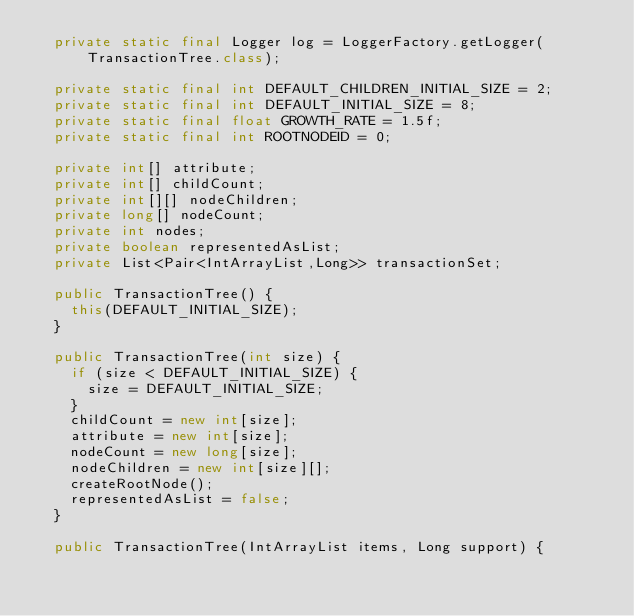Convert code to text. <code><loc_0><loc_0><loc_500><loc_500><_Java_>  private static final Logger log = LoggerFactory.getLogger(TransactionTree.class);

  private static final int DEFAULT_CHILDREN_INITIAL_SIZE = 2;
  private static final int DEFAULT_INITIAL_SIZE = 8;
  private static final float GROWTH_RATE = 1.5f;
  private static final int ROOTNODEID = 0;
  
  private int[] attribute;
  private int[] childCount;
  private int[][] nodeChildren;
  private long[] nodeCount;
  private int nodes;
  private boolean representedAsList;
  private List<Pair<IntArrayList,Long>> transactionSet;
  
  public TransactionTree() {
    this(DEFAULT_INITIAL_SIZE);
  }
  
  public TransactionTree(int size) {
    if (size < DEFAULT_INITIAL_SIZE) {
      size = DEFAULT_INITIAL_SIZE;
    }
    childCount = new int[size];
    attribute = new int[size];
    nodeCount = new long[size];
    nodeChildren = new int[size][];
    createRootNode();
    representedAsList = false;
  }

  public TransactionTree(IntArrayList items, Long support) {</code> 